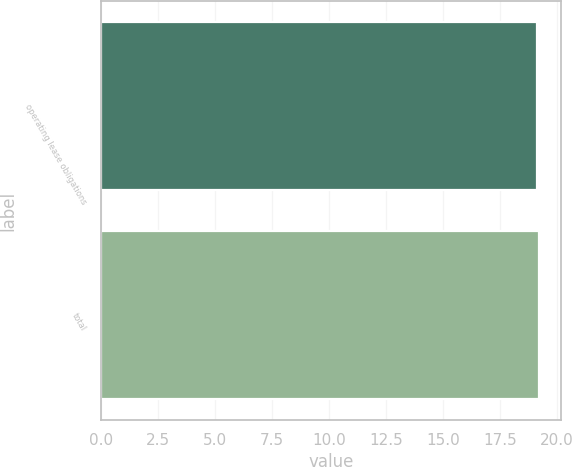Convert chart to OTSL. <chart><loc_0><loc_0><loc_500><loc_500><bar_chart><fcel>operating lease obligations<fcel>total<nl><fcel>19.1<fcel>19.2<nl></chart> 